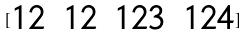Convert formula to latex. <formula><loc_0><loc_0><loc_500><loc_500>[ \begin{matrix} 1 2 & 1 2 & 1 2 3 & 1 2 4 \\ \end{matrix} ]</formula> 